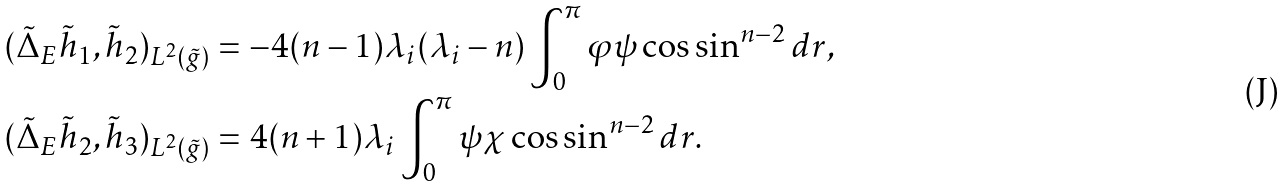<formula> <loc_0><loc_0><loc_500><loc_500>( \tilde { \Delta } _ { E } \tilde { h } _ { 1 } , \tilde { h } _ { 2 } ) _ { L ^ { 2 } ( \tilde { g } ) } & = - 4 ( n - 1 ) \lambda _ { i } ( \lambda _ { i } - n ) \int _ { 0 } ^ { \pi } \varphi \psi \cos \sin ^ { n - 2 } d r , \\ ( \tilde { \Delta } _ { E } \tilde { h } _ { 2 } , \tilde { h } _ { 3 } ) _ { L ^ { 2 } ( \tilde { g } ) } & = 4 ( n + 1 ) \lambda _ { i } \int _ { 0 } ^ { \pi } \psi \chi \cos \sin ^ { n - 2 } d r .</formula> 